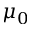<formula> <loc_0><loc_0><loc_500><loc_500>\mu _ { 0 }</formula> 